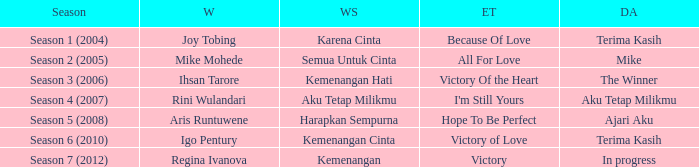Which winning song had a debut album in progress? Kemenangan. Parse the table in full. {'header': ['Season', 'W', 'WS', 'ET', 'DA'], 'rows': [['Season 1 (2004)', 'Joy Tobing', 'Karena Cinta', 'Because Of Love', 'Terima Kasih'], ['Season 2 (2005)', 'Mike Mohede', 'Semua Untuk Cinta', 'All For Love', 'Mike'], ['Season 3 (2006)', 'Ihsan Tarore', 'Kemenangan Hati', 'Victory Of the Heart', 'The Winner'], ['Season 4 (2007)', 'Rini Wulandari', 'Aku Tetap Milikmu', "I'm Still Yours", 'Aku Tetap Milikmu'], ['Season 5 (2008)', 'Aris Runtuwene', 'Harapkan Sempurna', 'Hope To Be Perfect', 'Ajari Aku'], ['Season 6 (2010)', 'Igo Pentury', 'Kemenangan Cinta', 'Victory of Love', 'Terima Kasih'], ['Season 7 (2012)', 'Regina Ivanova', 'Kemenangan', 'Victory', 'In progress']]} 